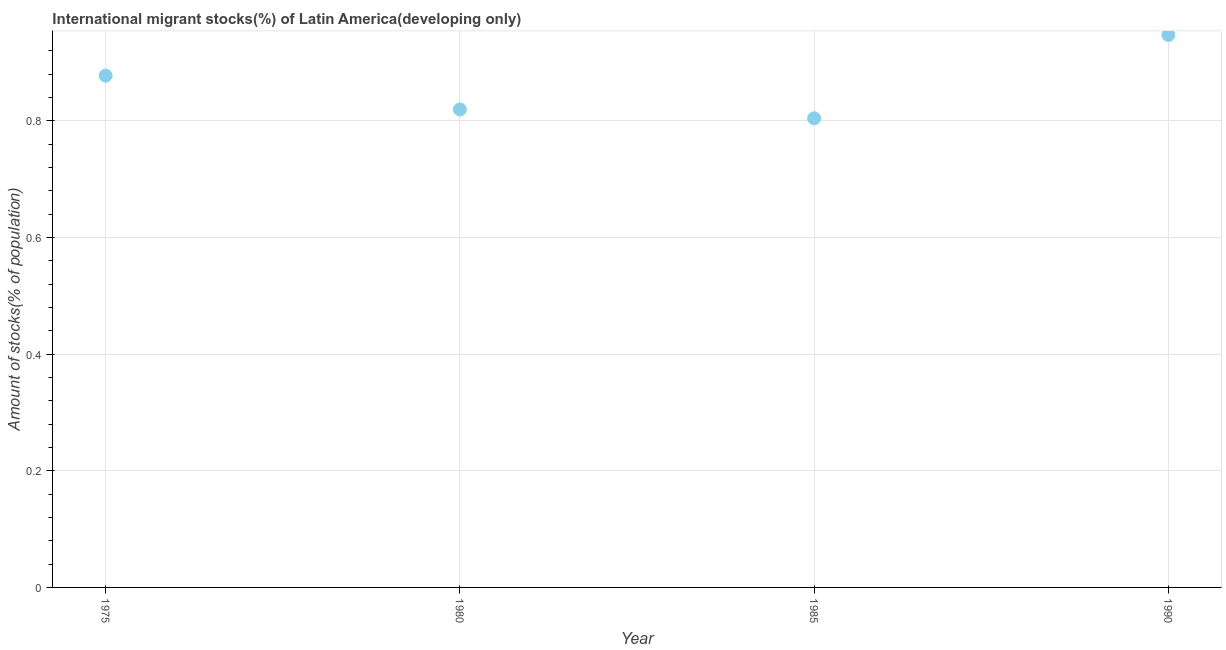What is the number of international migrant stocks in 1975?
Your answer should be very brief. 0.88. Across all years, what is the maximum number of international migrant stocks?
Ensure brevity in your answer.  0.95. Across all years, what is the minimum number of international migrant stocks?
Ensure brevity in your answer.  0.8. In which year was the number of international migrant stocks maximum?
Offer a very short reply. 1990. What is the sum of the number of international migrant stocks?
Your answer should be compact. 3.45. What is the difference between the number of international migrant stocks in 1985 and 1990?
Keep it short and to the point. -0.14. What is the average number of international migrant stocks per year?
Keep it short and to the point. 0.86. What is the median number of international migrant stocks?
Offer a terse response. 0.85. In how many years, is the number of international migrant stocks greater than 0.08 %?
Your answer should be very brief. 4. Do a majority of the years between 1990 and 1985 (inclusive) have number of international migrant stocks greater than 0.88 %?
Keep it short and to the point. No. What is the ratio of the number of international migrant stocks in 1975 to that in 1990?
Ensure brevity in your answer.  0.93. What is the difference between the highest and the second highest number of international migrant stocks?
Provide a short and direct response. 0.07. Is the sum of the number of international migrant stocks in 1975 and 1990 greater than the maximum number of international migrant stocks across all years?
Your answer should be very brief. Yes. What is the difference between the highest and the lowest number of international migrant stocks?
Provide a succinct answer. 0.14. In how many years, is the number of international migrant stocks greater than the average number of international migrant stocks taken over all years?
Your answer should be very brief. 2. How many years are there in the graph?
Your response must be concise. 4. Are the values on the major ticks of Y-axis written in scientific E-notation?
Provide a short and direct response. No. Does the graph contain any zero values?
Provide a short and direct response. No. What is the title of the graph?
Ensure brevity in your answer.  International migrant stocks(%) of Latin America(developing only). What is the label or title of the X-axis?
Your answer should be very brief. Year. What is the label or title of the Y-axis?
Ensure brevity in your answer.  Amount of stocks(% of population). What is the Amount of stocks(% of population) in 1975?
Provide a short and direct response. 0.88. What is the Amount of stocks(% of population) in 1980?
Your answer should be very brief. 0.82. What is the Amount of stocks(% of population) in 1985?
Provide a short and direct response. 0.8. What is the Amount of stocks(% of population) in 1990?
Give a very brief answer. 0.95. What is the difference between the Amount of stocks(% of population) in 1975 and 1980?
Make the answer very short. 0.06. What is the difference between the Amount of stocks(% of population) in 1975 and 1985?
Ensure brevity in your answer.  0.07. What is the difference between the Amount of stocks(% of population) in 1975 and 1990?
Your answer should be compact. -0.07. What is the difference between the Amount of stocks(% of population) in 1980 and 1985?
Provide a short and direct response. 0.02. What is the difference between the Amount of stocks(% of population) in 1980 and 1990?
Offer a terse response. -0.13. What is the difference between the Amount of stocks(% of population) in 1985 and 1990?
Make the answer very short. -0.14. What is the ratio of the Amount of stocks(% of population) in 1975 to that in 1980?
Ensure brevity in your answer.  1.07. What is the ratio of the Amount of stocks(% of population) in 1975 to that in 1985?
Provide a short and direct response. 1.09. What is the ratio of the Amount of stocks(% of population) in 1975 to that in 1990?
Give a very brief answer. 0.93. What is the ratio of the Amount of stocks(% of population) in 1980 to that in 1990?
Offer a terse response. 0.86. What is the ratio of the Amount of stocks(% of population) in 1985 to that in 1990?
Provide a short and direct response. 0.85. 